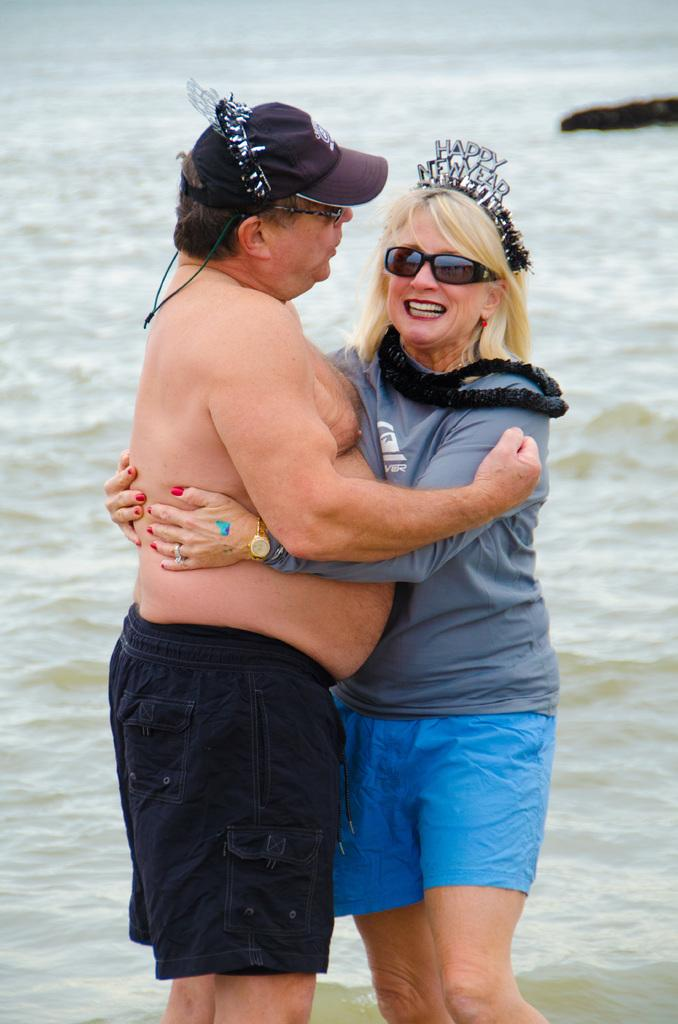Who are the two people in the image? There is a man and a lady in the image. What are the man and the lady doing in the image? The man and the lady are hugging each other. What can be seen in the background of the image? There is water and rocks visible in the background of the image. How many trucks can be seen in the image? There are no trucks present in the image. What is the value of the cent in the image? There is no cent present in the image. 